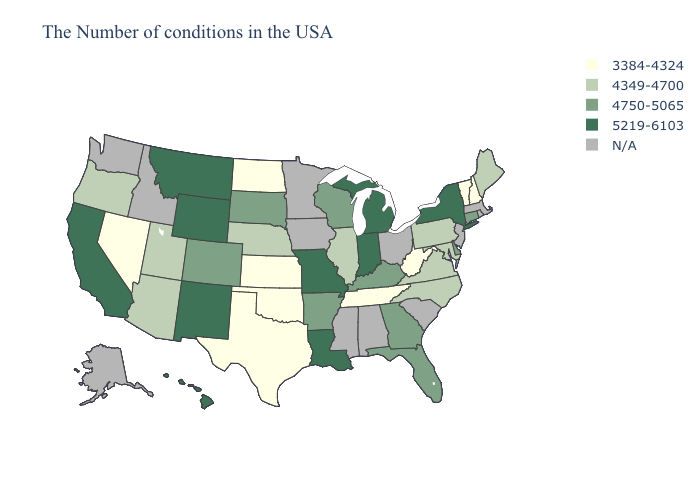What is the value of Arizona?
Keep it brief. 4349-4700. Name the states that have a value in the range 5219-6103?
Give a very brief answer. New York, Michigan, Indiana, Louisiana, Missouri, Wyoming, New Mexico, Montana, California, Hawaii. Does South Dakota have the lowest value in the MidWest?
Write a very short answer. No. Name the states that have a value in the range N/A?
Be succinct. Massachusetts, Rhode Island, New Jersey, South Carolina, Ohio, Alabama, Mississippi, Minnesota, Iowa, Idaho, Washington, Alaska. What is the value of Delaware?
Concise answer only. 4750-5065. Which states have the lowest value in the USA?
Short answer required. New Hampshire, Vermont, West Virginia, Tennessee, Kansas, Oklahoma, Texas, North Dakota, Nevada. How many symbols are there in the legend?
Answer briefly. 5. Which states have the highest value in the USA?
Be succinct. New York, Michigan, Indiana, Louisiana, Missouri, Wyoming, New Mexico, Montana, California, Hawaii. Does Arizona have the highest value in the West?
Be succinct. No. Among the states that border Tennessee , which have the highest value?
Quick response, please. Missouri. What is the highest value in the Northeast ?
Keep it brief. 5219-6103. Name the states that have a value in the range N/A?
Be succinct. Massachusetts, Rhode Island, New Jersey, South Carolina, Ohio, Alabama, Mississippi, Minnesota, Iowa, Idaho, Washington, Alaska. Name the states that have a value in the range 3384-4324?
Keep it brief. New Hampshire, Vermont, West Virginia, Tennessee, Kansas, Oklahoma, Texas, North Dakota, Nevada. 